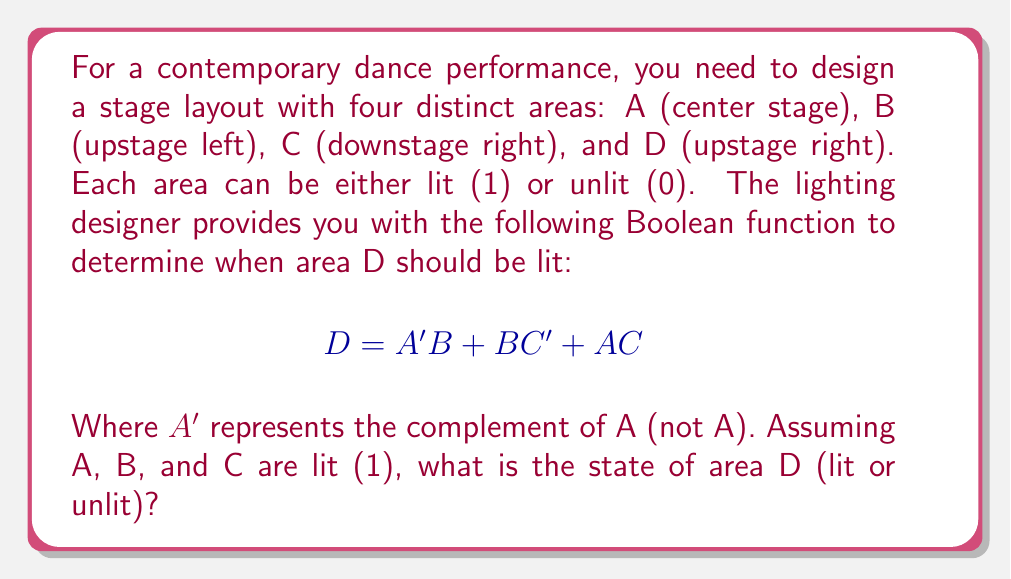Can you answer this question? Let's approach this step-by-step:

1) We're given that A = 1, B = 1, and C = 1.

2) Let's evaluate each term of the Boolean function:

   a) $A'B$:
      $A' = 0$ (since A = 1, its complement is 0)
      $A'B = 0 \cdot 1 = 0$

   b) $BC'$:
      $C' = 0$ (since C = 1, its complement is 0)
      $BC' = 1 \cdot 0 = 0$

   c) $AC$:
      $AC = 1 \cdot 1 = 1$

3) Now, we combine these terms using OR operations:

   $D = A'B + BC' + AC$
   $D = 0 + 0 + 1$
   $D = 1$

4) In Boolean algebra, any non-zero value is considered true or "on", which in this case means "lit".

Therefore, area D will be lit.
Answer: Lit (1) 